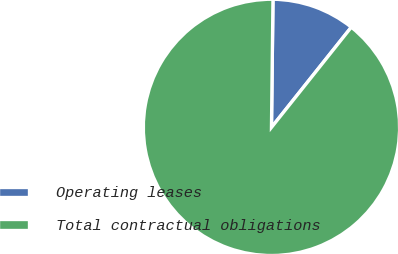Convert chart to OTSL. <chart><loc_0><loc_0><loc_500><loc_500><pie_chart><fcel>Operating leases<fcel>Total contractual obligations<nl><fcel>10.52%<fcel>89.48%<nl></chart> 